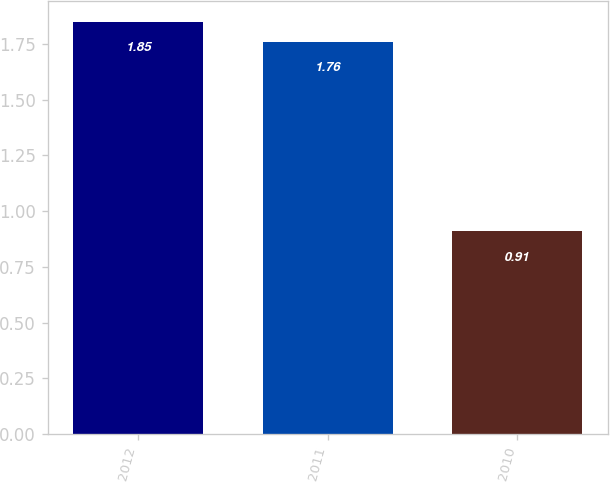Convert chart. <chart><loc_0><loc_0><loc_500><loc_500><bar_chart><fcel>2012<fcel>2011<fcel>2010<nl><fcel>1.85<fcel>1.76<fcel>0.91<nl></chart> 